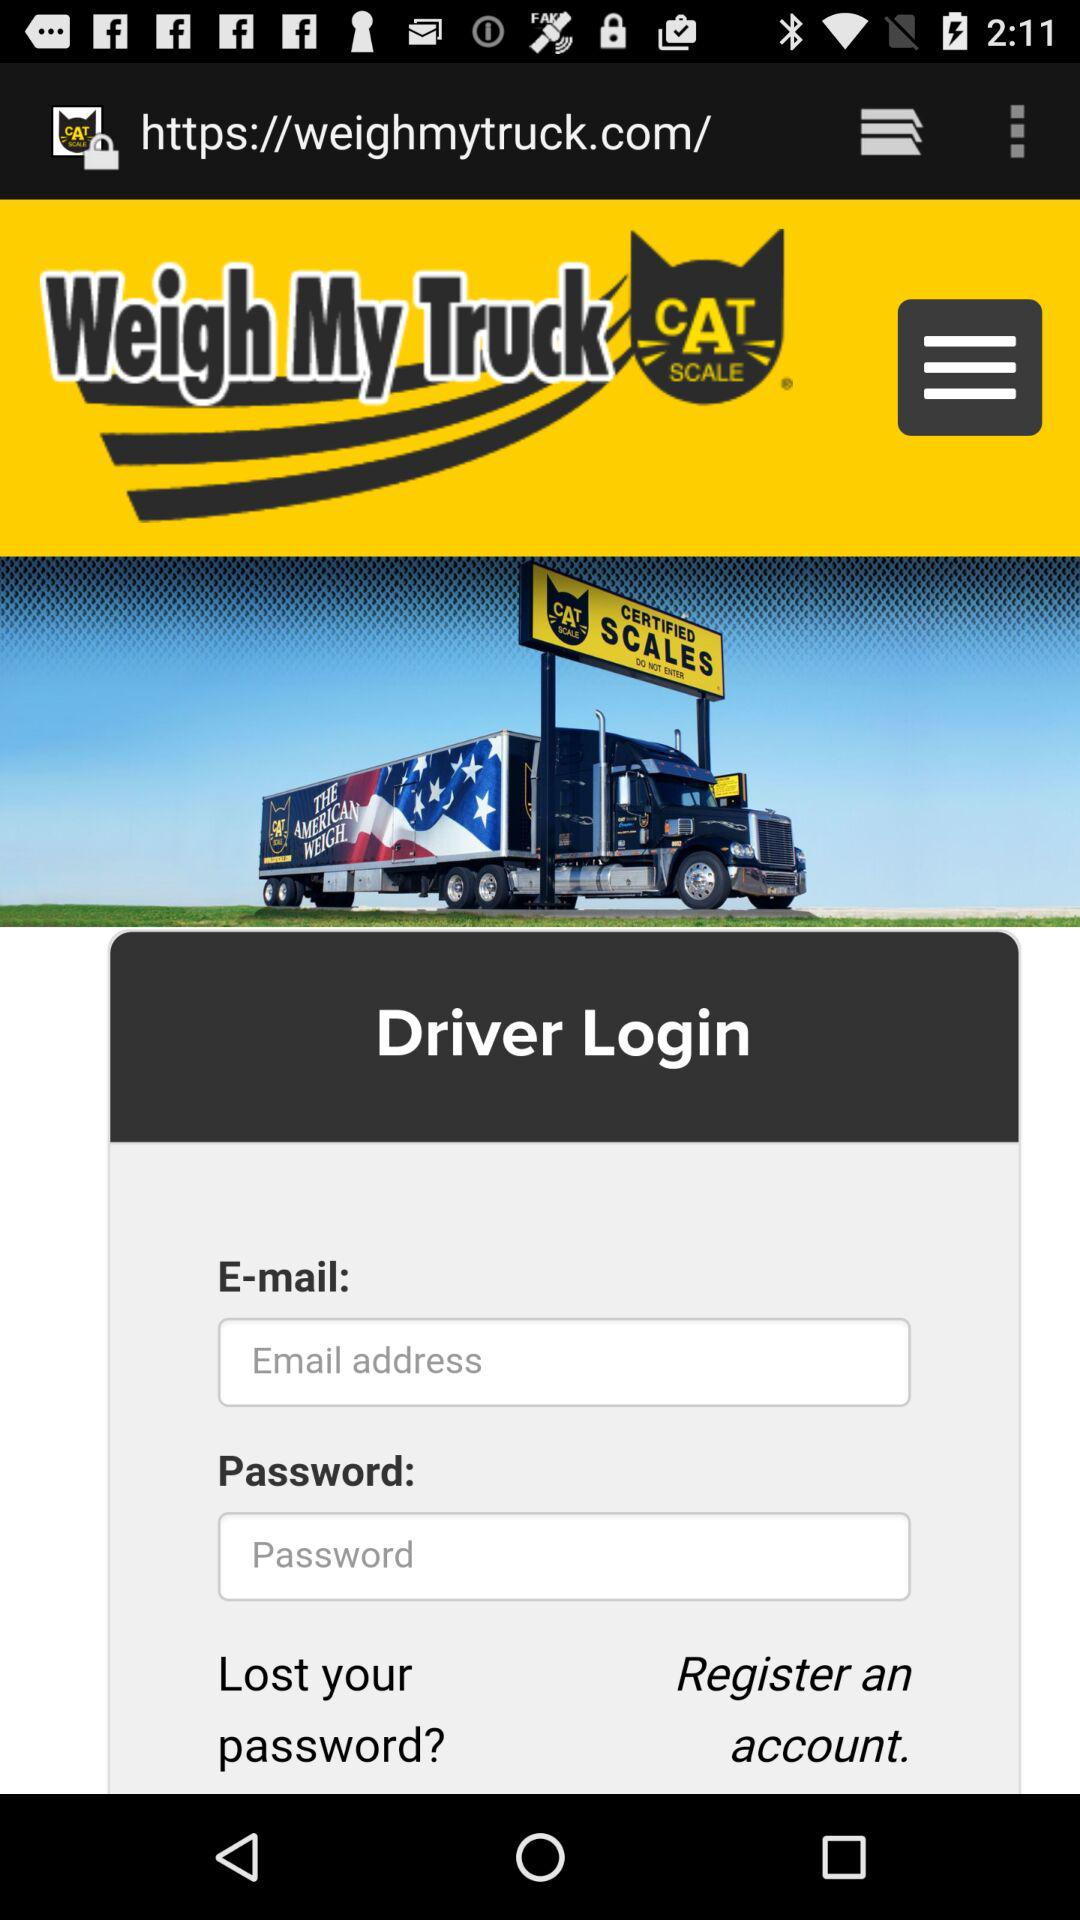How many text inputs are in the login form?
Answer the question using a single word or phrase. 2 